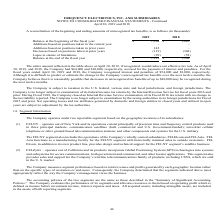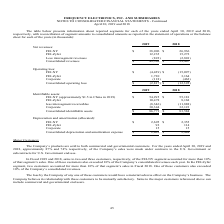From Frequency Electronics's financial document, What are the net revenues from FEI-NY in 2019 and 2018 respectively? The document shows two values: $38,096 and $26,936 (in thousands). From the document: "FEI-NY $ 38,096 $ 26,936 FEI-Zyfer 12,235 15,272 Less intersegment revenues (822 ) (2,801) Consolidated revenues $ FEI-NY $ 38,096 $ 26,936 FEI-Zyfer ..." Also, What are the net revenues from FEI-Zyfer in 2019 and 2018 respectively? The document shows two values: 12,235 and 15,272 (in thousands). From the document: "FEI-NY $ 38,096 $ 26,936 FEI-Zyfer 12,235 15,272 Less intersegment revenues (822 ) (2,801) Consolidated revenues $ 49,509 $ 39,407 FEI-NY $ 38,096 $ 2..." Also, How does the company measure segment performance? based on total revenues and profits generated by each geographic location. The document states: "market. The Company measures segment performance based on total revenues and profits generated by each geographic location rather than on the specific..." Also, can you calculate: What is the change in net revenues from FEI-NY between 2018 and 2019? Based on the calculation: 38,096-26,936, the result is 11160 (in thousands). This is based on the information: "FEI-NY $ 38,096 $ 26,936 FEI-Zyfer 12,235 15,272 Less intersegment revenues (822 ) (2,801) Consolidated revenues $ 49,509 $ FEI-NY $ 38,096 $ 26,936 FEI-Zyfer 12,235 15,272 Less intersegment revenues ..." The key data points involved are: 26,936, 38,096. Also, can you calculate: What is the average net revenue from FEI-Zyfer in 2018 and 2019? To answer this question, I need to perform calculations using the financial data. The calculation is: (12,235+15,272)/2, which equals 13753.5 (in thousands). This is based on the information: "FEI-NY $ 38,096 $ 26,936 FEI-Zyfer 12,235 15,272 Less intersegment revenues (822 ) (2,801) Consolidated revenues $ 49,509 $ 39,407 FEI-NY $ 38,096 $ 26,936 FEI-Zyfer 12,235 15,272 Less intersegment re..." The key data points involved are: 12,235, 15,272. Also, can you calculate: In 2019, what is the percentage constitution of the revenue from FEI-NY among the total consolidated revenues? Based on the calculation: 38,096/49,509, the result is 76.95 (percentage). This is based on the information: "t revenues (822 ) (2,801) Consolidated revenues $ 49,509 $ 39,407 FEI-NY $ 38,096 $ 26,936 FEI-Zyfer 12,235 15,272 Less intersegment revenues (822 ) (2,801) Consolidated revenues $..." The key data points involved are: 38,096, 49,509. 